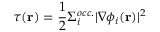<formula> <loc_0><loc_0><loc_500><loc_500>\tau ( r ) = \frac { 1 } { 2 } \Sigma _ { i } ^ { o c c . } | \nabla \phi _ { i } ( r ) | ^ { 2 }</formula> 